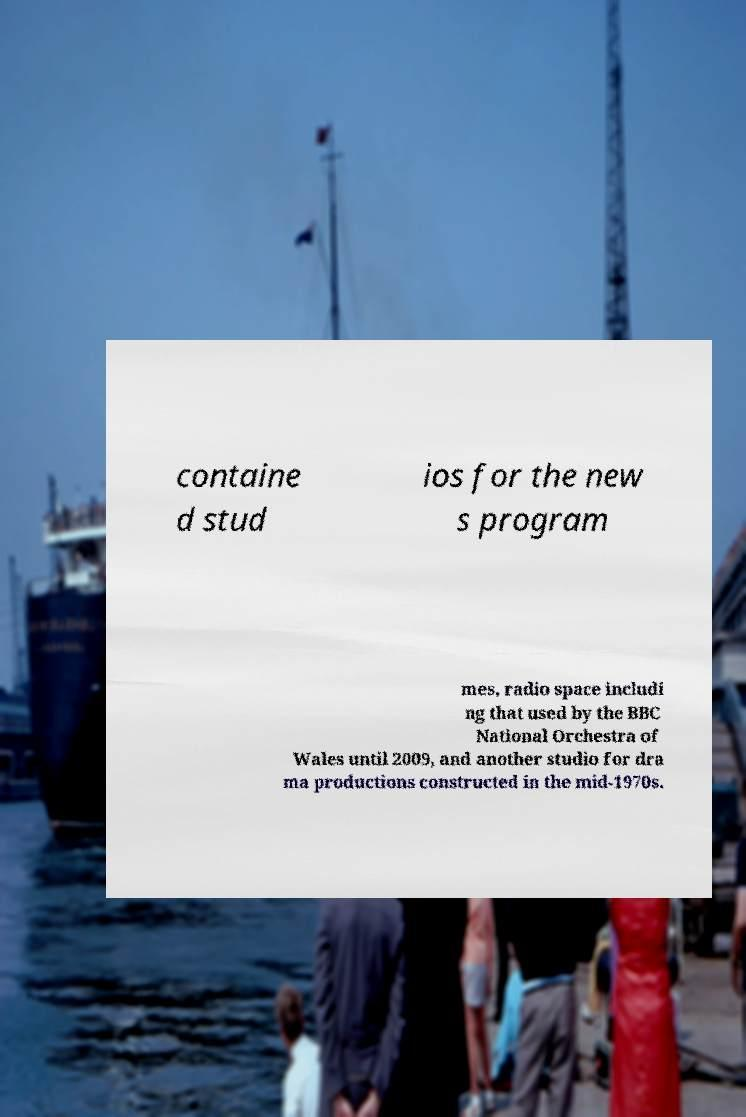For documentation purposes, I need the text within this image transcribed. Could you provide that? containe d stud ios for the new s program mes, radio space includi ng that used by the BBC National Orchestra of Wales until 2009, and another studio for dra ma productions constructed in the mid-1970s. 